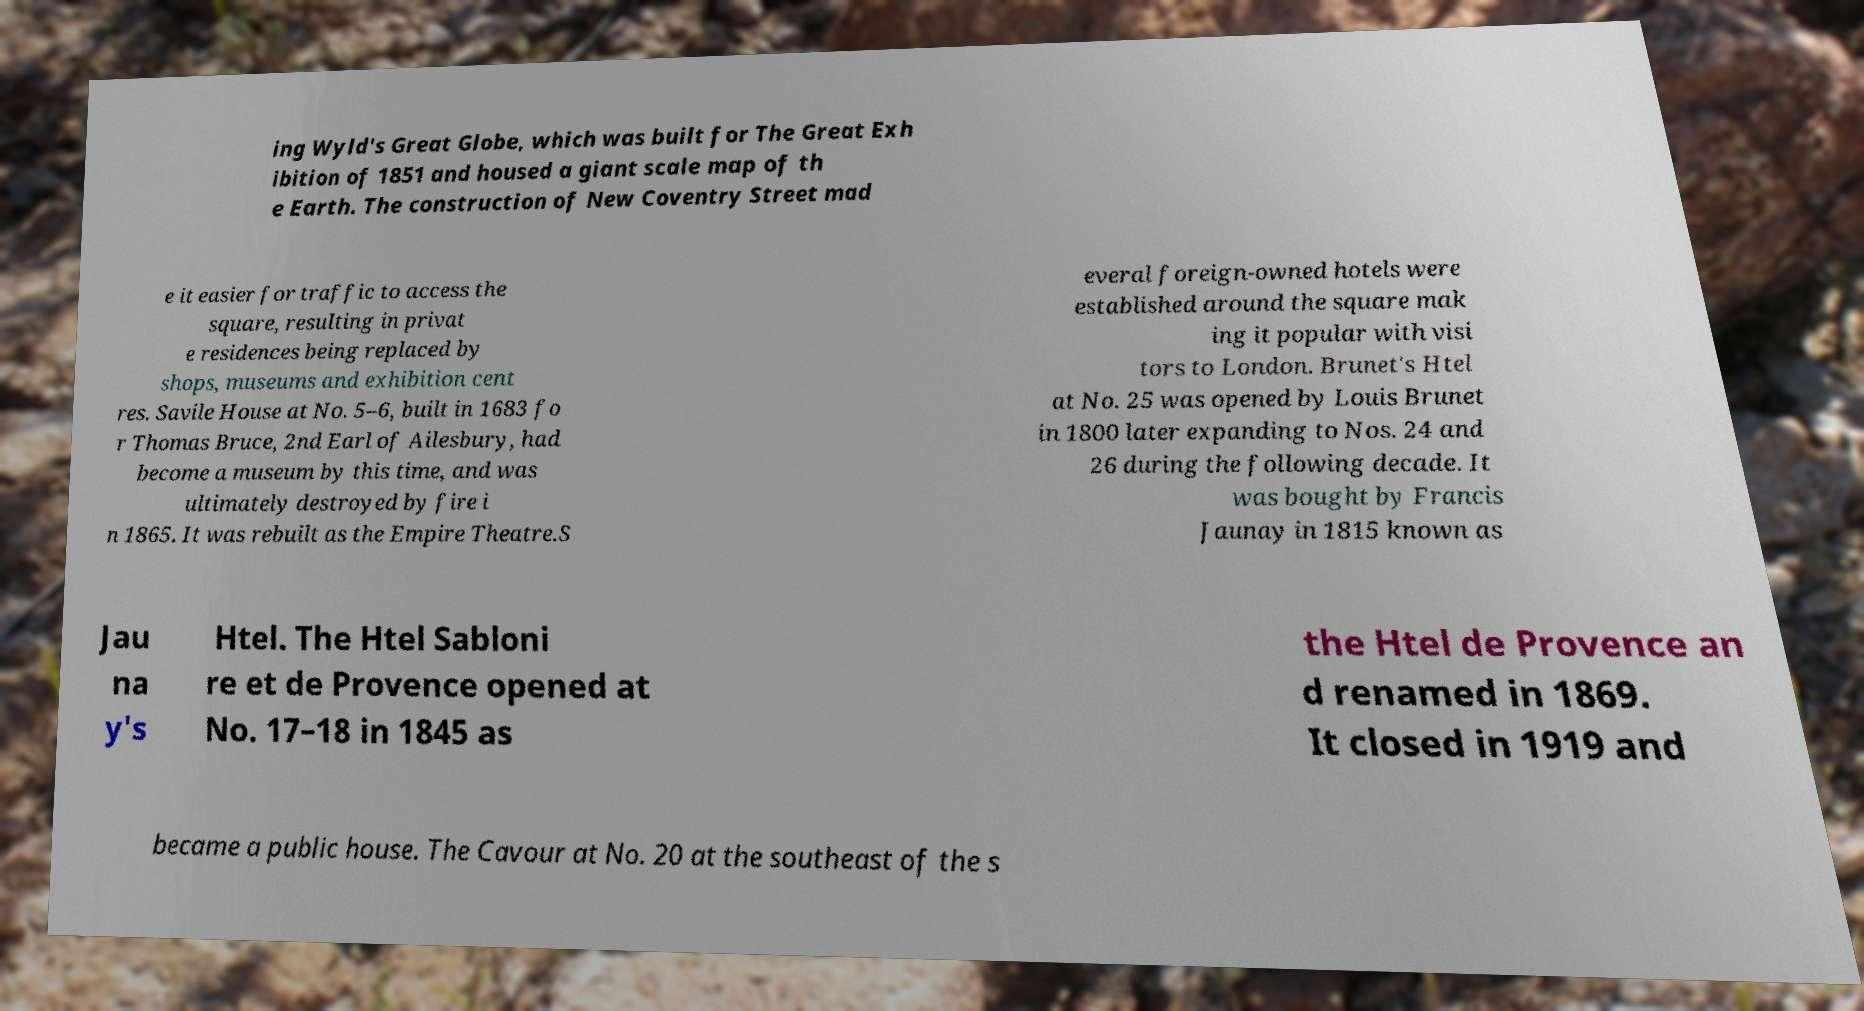Please read and relay the text visible in this image. What does it say? ing Wyld's Great Globe, which was built for The Great Exh ibition of 1851 and housed a giant scale map of th e Earth. The construction of New Coventry Street mad e it easier for traffic to access the square, resulting in privat e residences being replaced by shops, museums and exhibition cent res. Savile House at No. 5–6, built in 1683 fo r Thomas Bruce, 2nd Earl of Ailesbury, had become a museum by this time, and was ultimately destroyed by fire i n 1865. It was rebuilt as the Empire Theatre.S everal foreign-owned hotels were established around the square mak ing it popular with visi tors to London. Brunet's Htel at No. 25 was opened by Louis Brunet in 1800 later expanding to Nos. 24 and 26 during the following decade. It was bought by Francis Jaunay in 1815 known as Jau na y's Htel. The Htel Sabloni re et de Provence opened at No. 17–18 in 1845 as the Htel de Provence an d renamed in 1869. It closed in 1919 and became a public house. The Cavour at No. 20 at the southeast of the s 